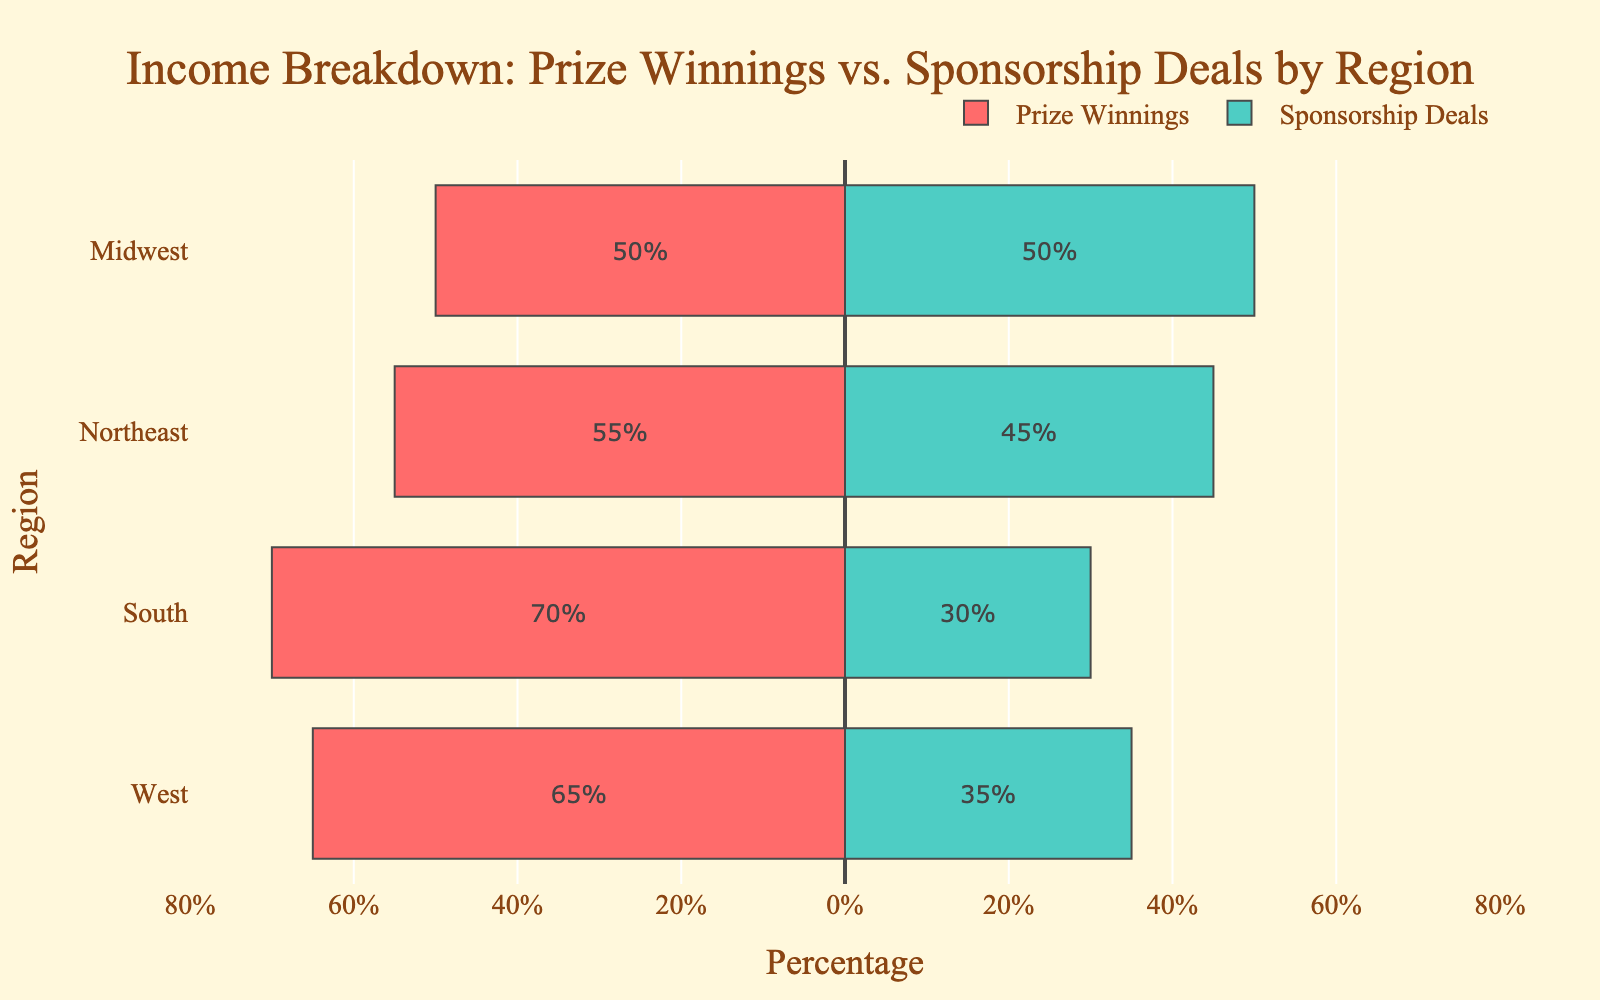What region has the highest percentage of income from Prize Winnings? The South region has the highest percentage of income from Prize Winnings, which is 70%. This can be determined by looking at the red bar's length and comparing it across the regions.
Answer: South Which region has an equal distribution of income from Prize Winnings and Sponsorship Deals? The Midwest region has equal distribution of income from Prize Winnings and Sponsorship Deals, both at 50%, as shown by the equal lengths of the red and green bars.
Answer: Midwest What is the total percentage of income from Prize Winnings for the West and Northeast regions combined? The percentages for Prize Winnings in the West and Northeast regions are 65% and 55%, respectively. Adding them together gives 65 + 55 = 120%.
Answer: 120% Which region relies more on Sponsorship Deals compared to Prize Winnings? The Midwest region has an equal reliance (50%) on Sponsorship Deals and Prize Winnings. However, the West region, with a Sponsorship Deal percentage of 35%, relies more heavily on Sponsorship Deals relative to its Prize Winnings percentage than the South or Northeast regions do.
Answer: West Compare the difference in income percentage from Prize Winnings between the South and Northeast regions. The South region has 70% income from Prize Winnings, while the Northeast region has 55%. The difference is 70 - 55 = 15%.
Answer: 15% Which region has the least reliance on Sponsorship Deals? The South region has the least reliance on Sponsorship Deals at 30%, shown by the shortest green bar.
Answer: South What is the average percentage of income from Prize Winnings across all the regions? Add the Prize Winnings percentages for all regions: 65% (West) + 50% (Midwest) + 70% (South) + 55% (Northeast) = 240%. Divide by the number of regions (4) to get the average: 240 / 4 = 60%.
Answer: 60% In which region is the disparity between income from Prize Winnings and Sponsorship Deals the smallest? The Midwest region has equal percentages (50%) for both Prize Winnings and Sponsorship Deals, meaning the disparity is 0%, which is the smallest.
Answer: Midwest How does the length of the bar representing Sponsorship Deals in the Northeast compare to that in the South? The Northeast region’s bar for Sponsorship Deals is at 45%, while in the South, it is 30%. The bar is longer for the Northeast, and the difference is 45 - 30 = 15%.
Answer: Longer by 15% What is the combined percentage of income from Sponsorship Deals in the West and Midwest regions? The Sponsorship Deals percentages for the West and Midwest regions are 35% and 50%, respectively. Adding them together gives 35 + 50 = 85%.
Answer: 85% 